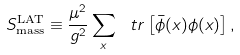Convert formula to latex. <formula><loc_0><loc_0><loc_500><loc_500>S _ { \text {mass} } ^ { \text {LAT} } \equiv \frac { \mu ^ { 2 } } { g ^ { 2 } } \sum _ { x } \ t r \left [ \bar { \phi } ( x ) \phi ( x ) \right ] ,</formula> 